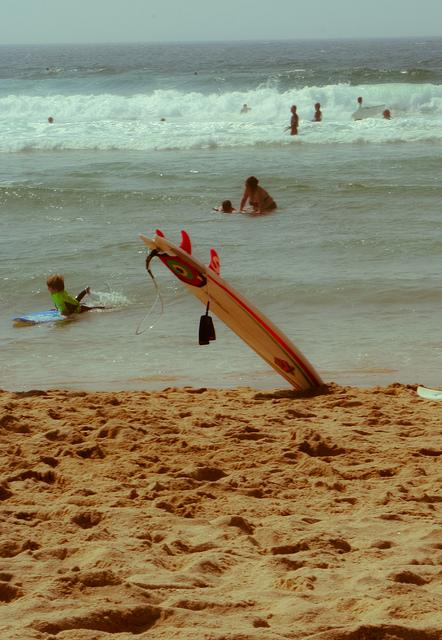What is in the sand? surfboard 